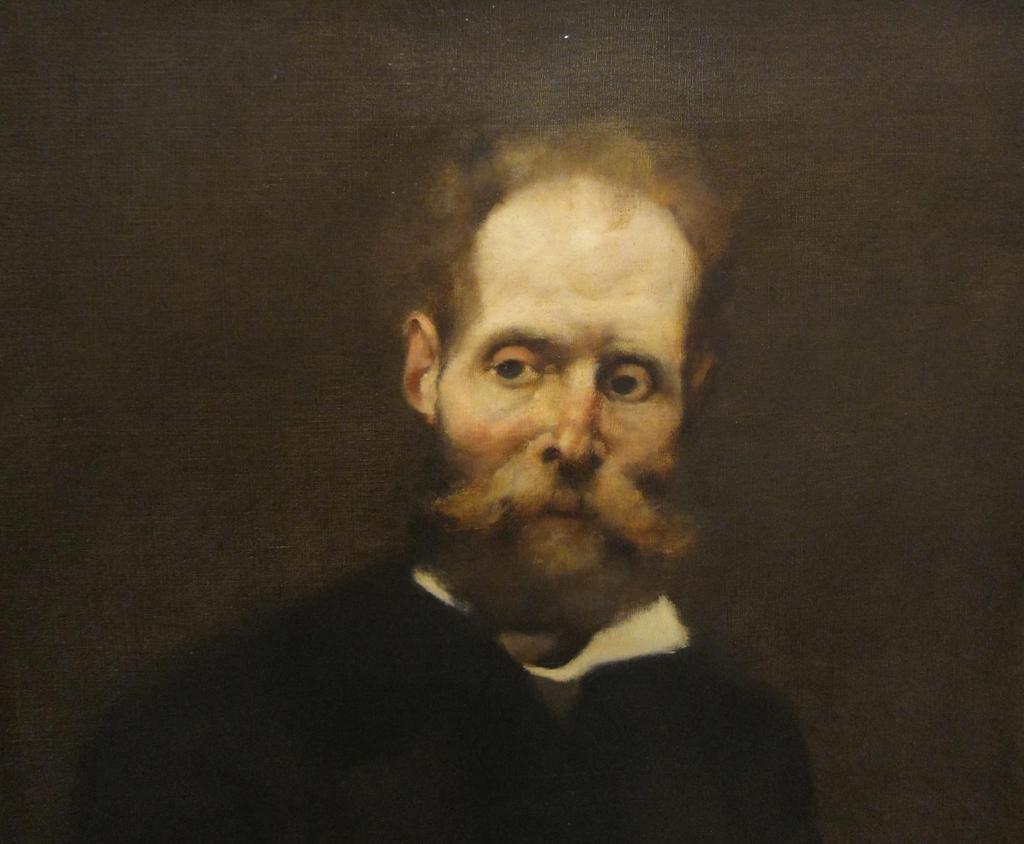How would you summarize this image in a sentence or two? In this image we can see a person. In the background of the image there is a dark background. 